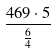Convert formula to latex. <formula><loc_0><loc_0><loc_500><loc_500>\frac { 4 6 9 \cdot 5 } { \frac { 6 } { 4 } }</formula> 